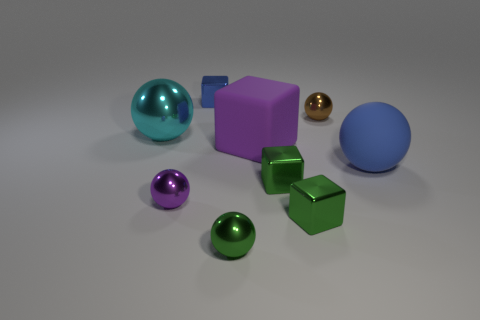Subtract all blue balls. How many balls are left? 4 Subtract all purple balls. How many balls are left? 4 Subtract all red balls. Subtract all gray blocks. How many balls are left? 5 Add 1 large red balls. How many objects exist? 10 Subtract all spheres. How many objects are left? 4 Subtract all small brown metallic balls. Subtract all blue rubber things. How many objects are left? 7 Add 6 brown shiny balls. How many brown shiny balls are left? 7 Add 1 large yellow rubber objects. How many large yellow rubber objects exist? 1 Subtract 2 green cubes. How many objects are left? 7 